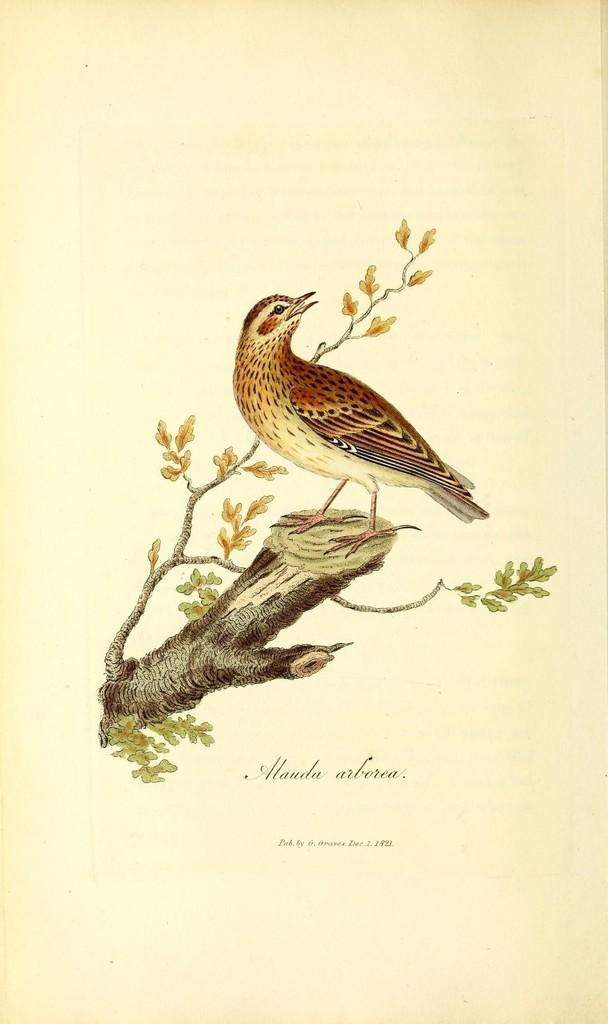What is the overall appearance of the image? The image resembles a page in a book. What can be seen in the center of the image? There are stems, leaves, and a branch in the center of the image. Is there any animal present in the image? Yes, there is a bird on the stem. What is located at the bottom of the image? There is text at the bottom of the image. How many matches are visible in the image? There are no matches present in the image. Is there a wheel visible in the image? There is no wheel present in the image. 